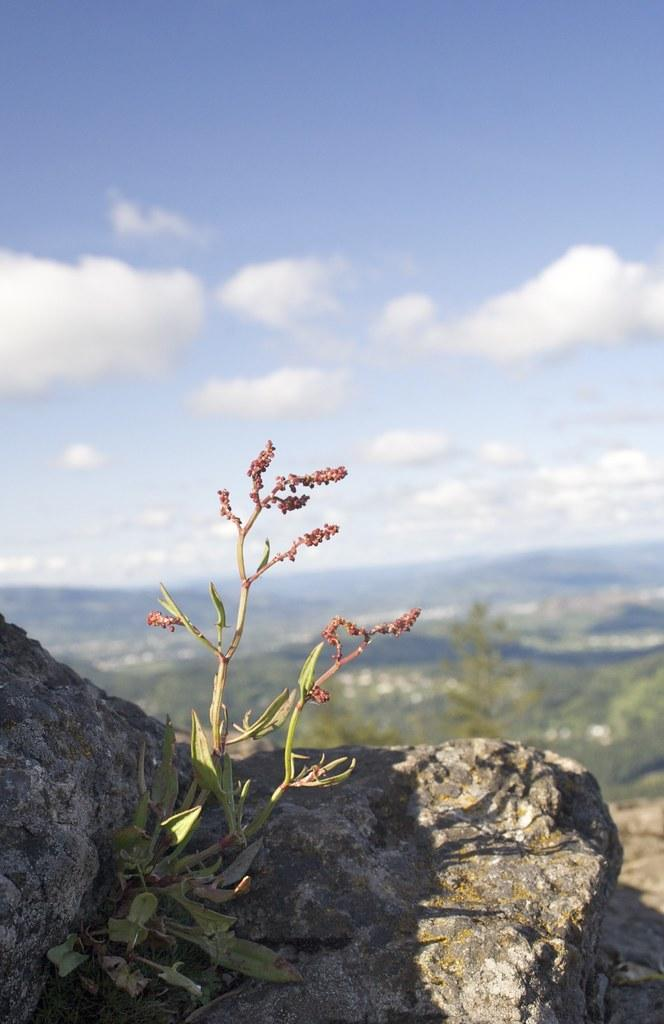What is located in the front of the image? There is a rock and a plant in the front of the image. What else can be seen in the front of the image besides the rock? There is a plant visible in the front of the image. What is visible in the background of the image? There are plants visible in the background of the image. What can be seen in the sky in the image? The sky is visible in the image, and clouds are present. Where is the cub located in the image? There is no cub present in the image. Can you tell me how many cars are visible in the image? There are no cars visible in the image. 